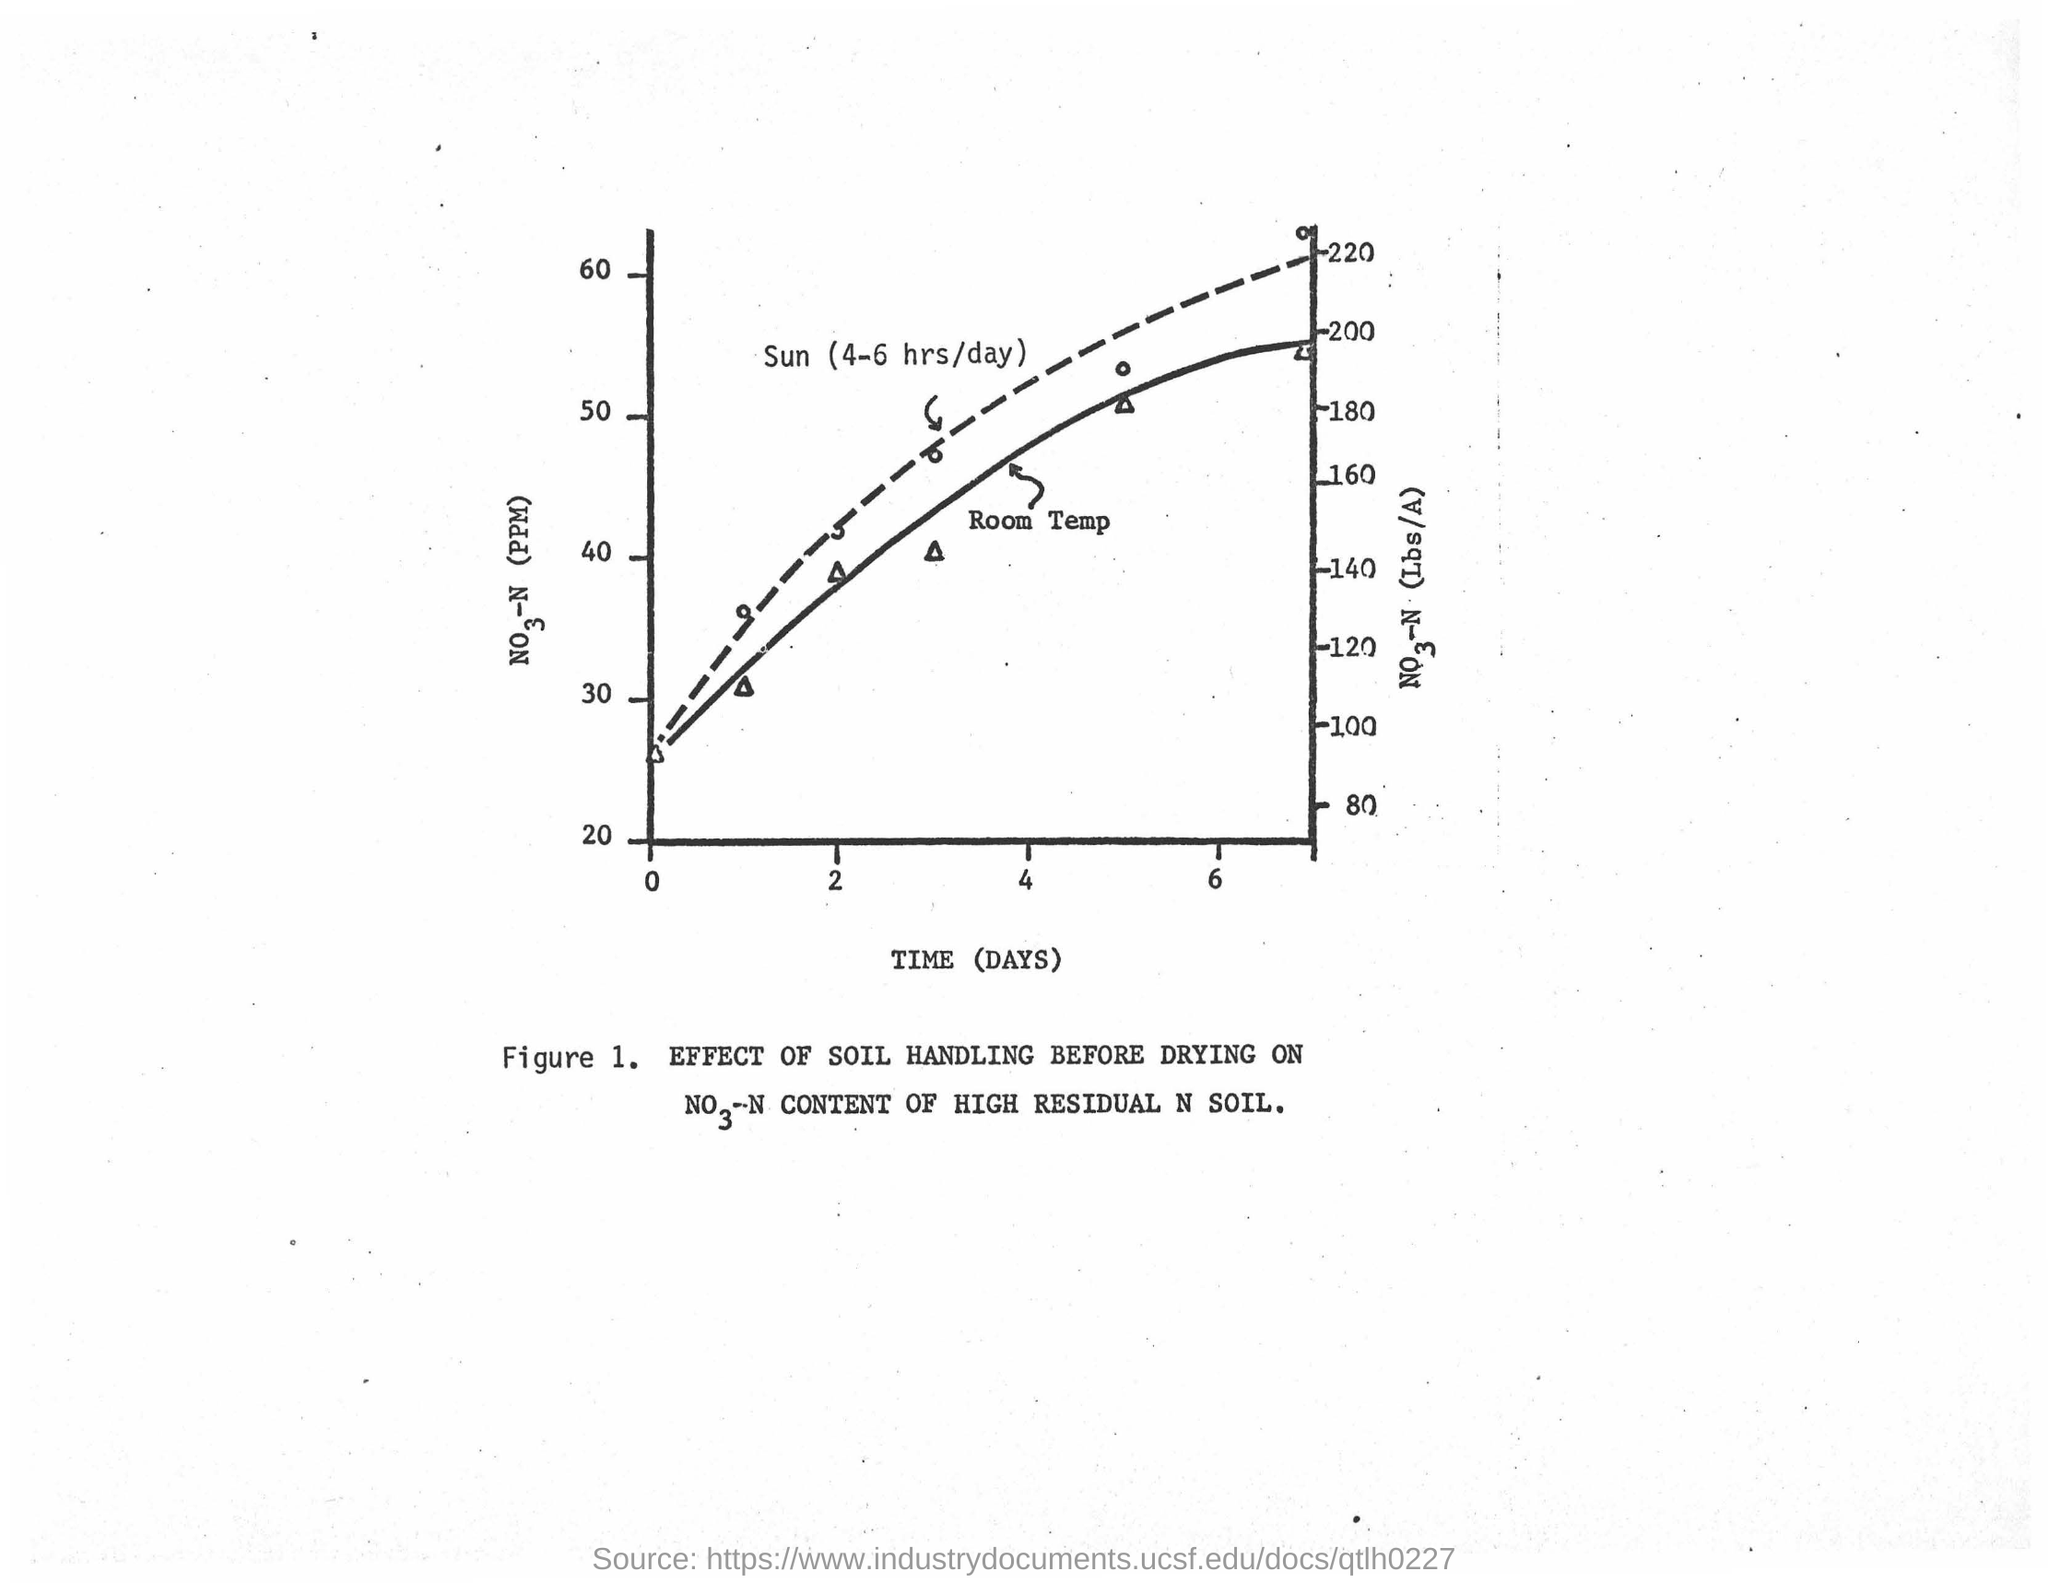In which unit is time plotted in this graph?
Make the answer very short. (DAYS). 